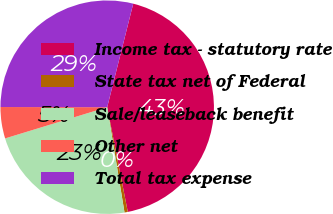<chart> <loc_0><loc_0><loc_500><loc_500><pie_chart><fcel>Income tax - statutory rate<fcel>State tax net of Federal<fcel>Sale/leaseback benefit<fcel>Other net<fcel>Total tax expense<nl><fcel>42.99%<fcel>0.5%<fcel>22.87%<fcel>4.75%<fcel>28.9%<nl></chart> 